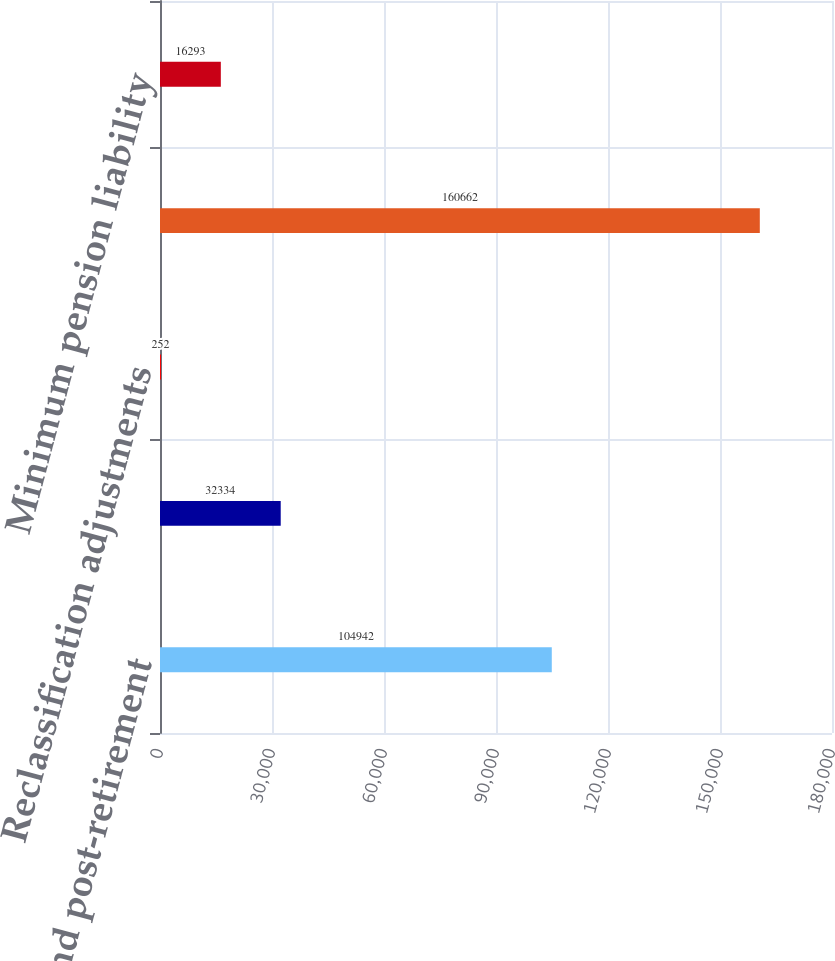Convert chart to OTSL. <chart><loc_0><loc_0><loc_500><loc_500><bar_chart><fcel>Pension and post-retirement<fcel>Gains (losses) on cash flow<fcel>Reclassification adjustments<fcel>Total other comprehensive<fcel>Minimum pension liability<nl><fcel>104942<fcel>32334<fcel>252<fcel>160662<fcel>16293<nl></chart> 